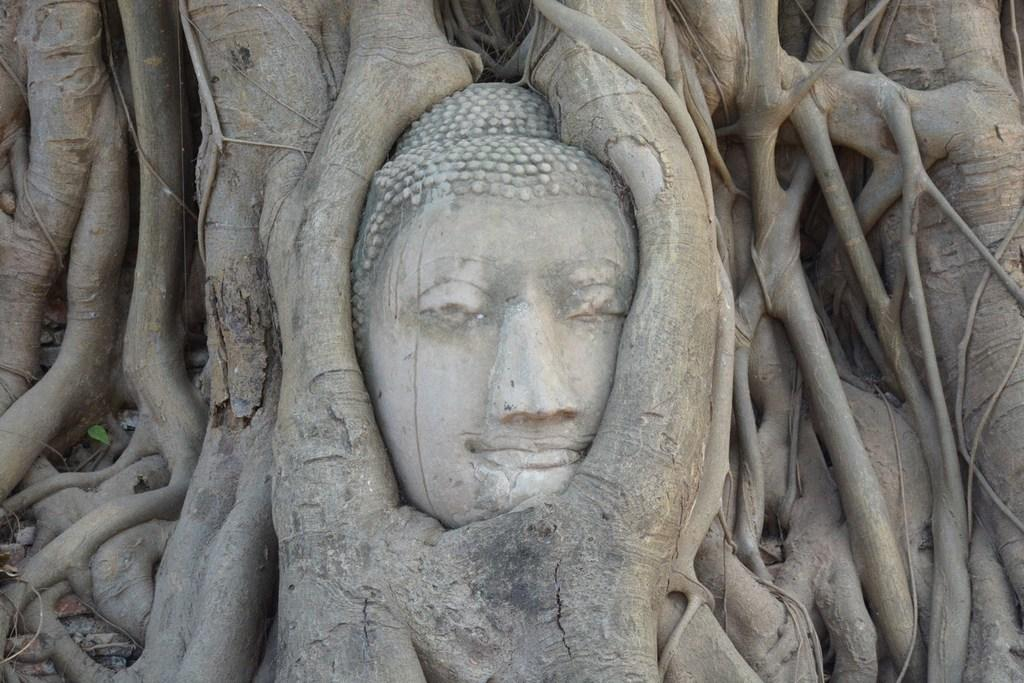Where was the image taken? The image was taken outdoors. What can be seen in the image besides the outdoor setting? There is a tree in the image. Can you describe the tree in more detail? The tree has stems and branches. What is unique about this tree? There is a sculpture of Buddha in the tree. Is there a river flowing near the tree in the image? No, there is no river visible in the image. Can you tell me what type of stove is being used to cook in the image? There is no stove present in the image. 